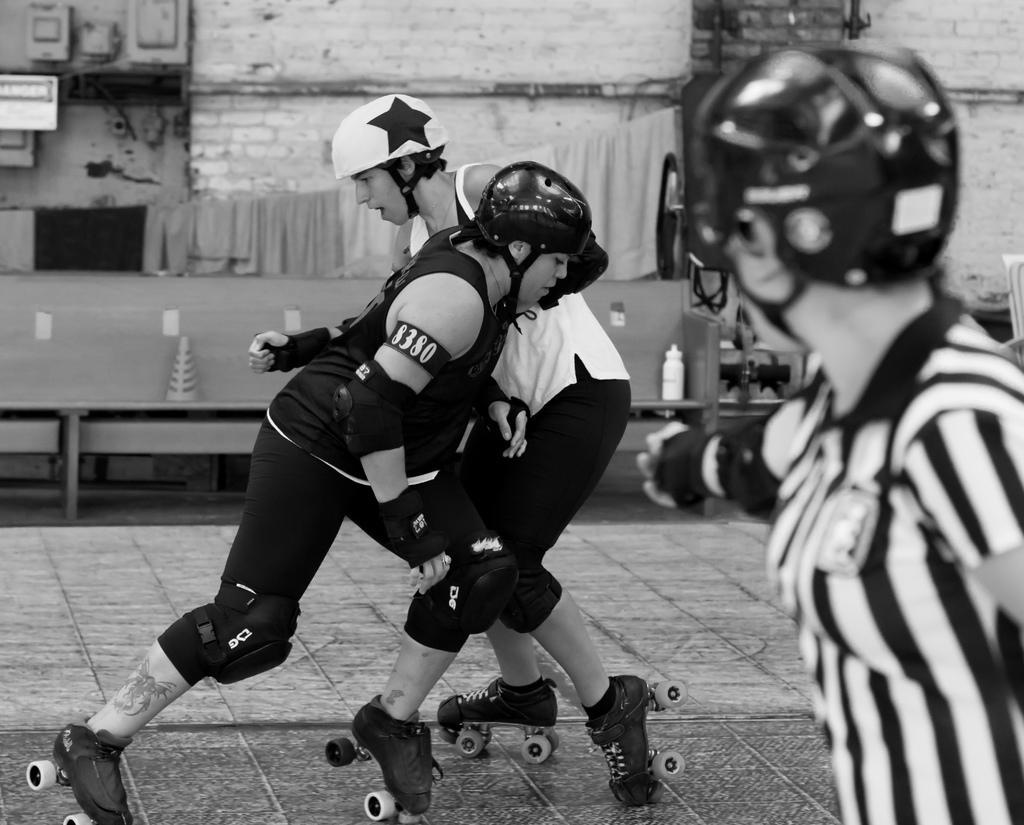How would you summarize this image in a sentence or two? Here in this picture we can see people skating on the floor with skating shoes on them and we can see they are wearing gloves, knee caps, elbow caps and helmets on them and beside them we can see a table, on which we can see a bottle present and we can see clothes hanging over there. 